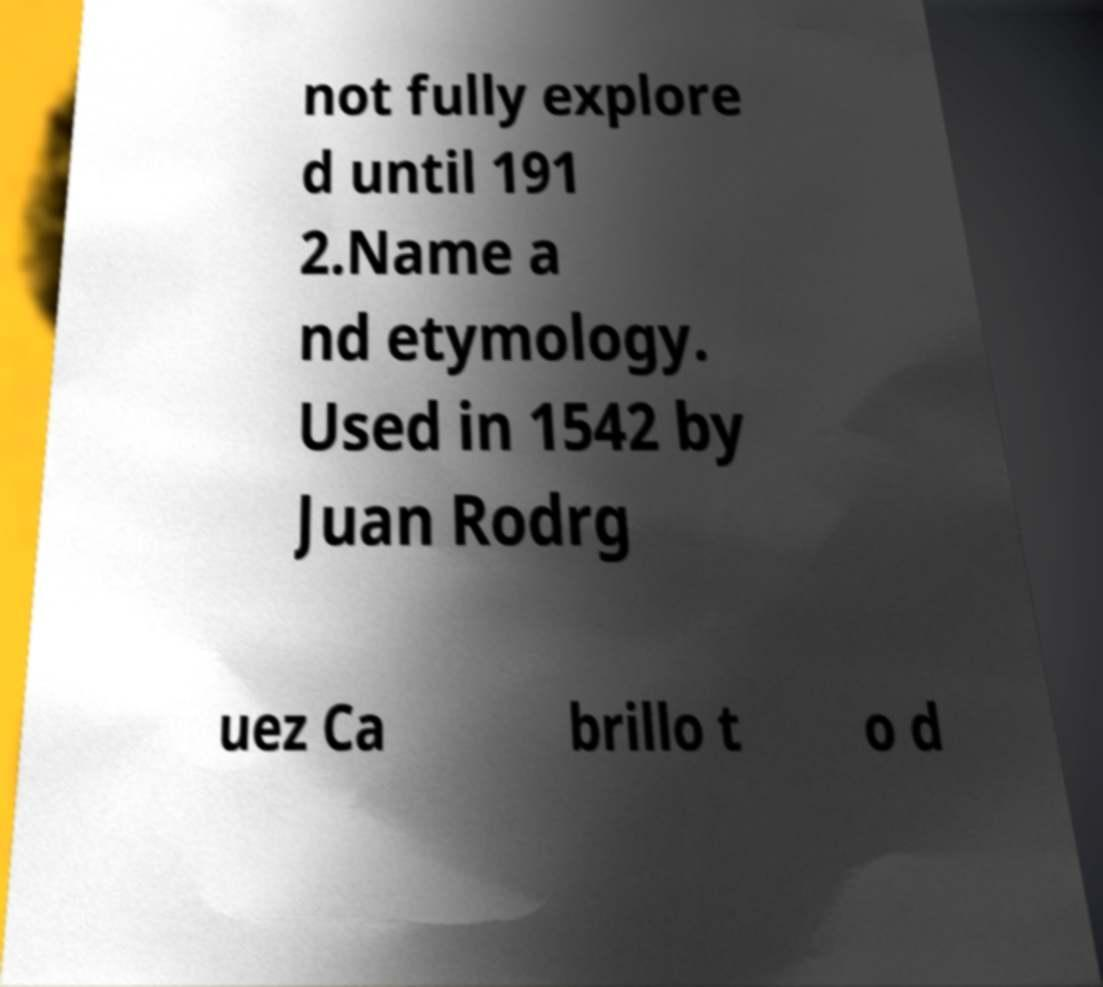Could you assist in decoding the text presented in this image and type it out clearly? not fully explore d until 191 2.Name a nd etymology. Used in 1542 by Juan Rodrg uez Ca brillo t o d 